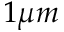<formula> <loc_0><loc_0><loc_500><loc_500>1 \mu m</formula> 